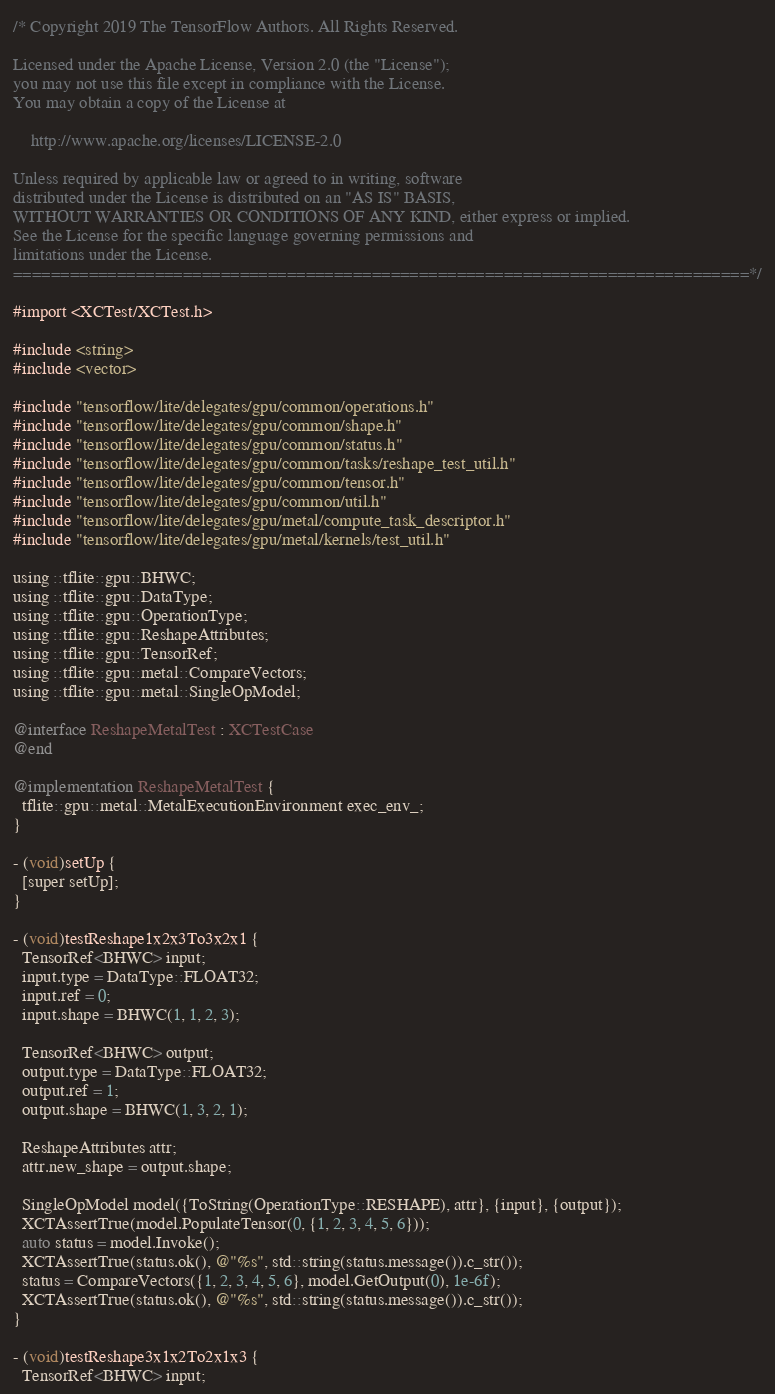<code> <loc_0><loc_0><loc_500><loc_500><_ObjectiveC_>/* Copyright 2019 The TensorFlow Authors. All Rights Reserved.

Licensed under the Apache License, Version 2.0 (the "License");
you may not use this file except in compliance with the License.
You may obtain a copy of the License at

    http://www.apache.org/licenses/LICENSE-2.0

Unless required by applicable law or agreed to in writing, software
distributed under the License is distributed on an "AS IS" BASIS,
WITHOUT WARRANTIES OR CONDITIONS OF ANY KIND, either express or implied.
See the License for the specific language governing permissions and
limitations under the License.
==============================================================================*/

#import <XCTest/XCTest.h>

#include <string>
#include <vector>

#include "tensorflow/lite/delegates/gpu/common/operations.h"
#include "tensorflow/lite/delegates/gpu/common/shape.h"
#include "tensorflow/lite/delegates/gpu/common/status.h"
#include "tensorflow/lite/delegates/gpu/common/tasks/reshape_test_util.h"
#include "tensorflow/lite/delegates/gpu/common/tensor.h"
#include "tensorflow/lite/delegates/gpu/common/util.h"
#include "tensorflow/lite/delegates/gpu/metal/compute_task_descriptor.h"
#include "tensorflow/lite/delegates/gpu/metal/kernels/test_util.h"

using ::tflite::gpu::BHWC;
using ::tflite::gpu::DataType;
using ::tflite::gpu::OperationType;
using ::tflite::gpu::ReshapeAttributes;
using ::tflite::gpu::TensorRef;
using ::tflite::gpu::metal::CompareVectors;
using ::tflite::gpu::metal::SingleOpModel;

@interface ReshapeMetalTest : XCTestCase
@end

@implementation ReshapeMetalTest {
  tflite::gpu::metal::MetalExecutionEnvironment exec_env_;
}

- (void)setUp {
  [super setUp];
}

- (void)testReshape1x2x3To3x2x1 {
  TensorRef<BHWC> input;
  input.type = DataType::FLOAT32;
  input.ref = 0;
  input.shape = BHWC(1, 1, 2, 3);

  TensorRef<BHWC> output;
  output.type = DataType::FLOAT32;
  output.ref = 1;
  output.shape = BHWC(1, 3, 2, 1);

  ReshapeAttributes attr;
  attr.new_shape = output.shape;

  SingleOpModel model({ToString(OperationType::RESHAPE), attr}, {input}, {output});
  XCTAssertTrue(model.PopulateTensor(0, {1, 2, 3, 4, 5, 6}));
  auto status = model.Invoke();
  XCTAssertTrue(status.ok(), @"%s", std::string(status.message()).c_str());
  status = CompareVectors({1, 2, 3, 4, 5, 6}, model.GetOutput(0), 1e-6f);
  XCTAssertTrue(status.ok(), @"%s", std::string(status.message()).c_str());
}

- (void)testReshape3x1x2To2x1x3 {
  TensorRef<BHWC> input;</code> 